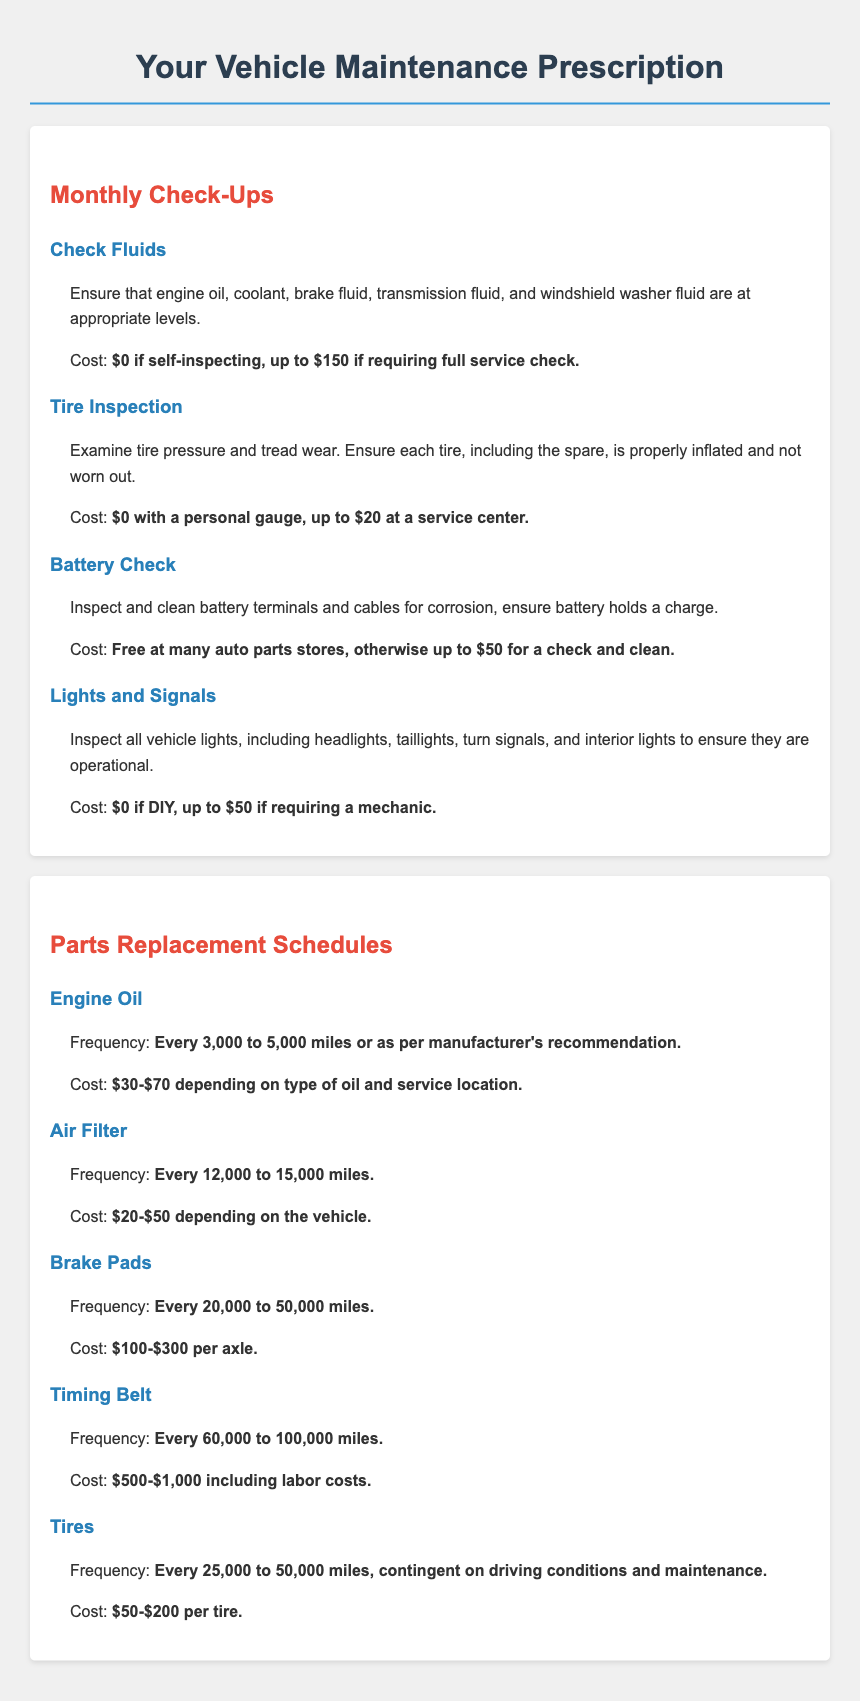What is the cost of checking fluids? The cost for checking fluids can range from $0 for self-inspecting to $150 if requiring a full service check.
Answer: $0 to $150 How often should you check tire pressure and tread wear? The document mentions that tire inspection should be done monthly.
Answer: Monthly What is the cost range for engine oil replacement? The cost for engine oil replacement depends on the type of oil and service location, ranging from $30 to $70.
Answer: $30-$70 When should brake pads typically be replaced? Brake pads should be replaced every 20,000 to 50,000 miles.
Answer: Every 20,000 to 50,000 miles What is the frequency for replacing the air filter? It is recommended to replace the air filter every 12,000 to 15,000 miles.
Answer: Every 12,000 to 15,000 miles How much might you spend on a tire replacement? The document states that tire cost ranges from $50 to $200 per tire.
Answer: $50-$200 What can be done to check the battery? Battery check involves inspecting and cleaning battery terminals and cables.
Answer: Inspect and clean terminals What is the maximum cost for a light and signal inspection? If requiring a mechanic, the maximum cost for light and signal inspection can be up to $50.
Answer: Up to $50 How frequently should the timing belt be replaced? The timing belt should be replaced every 60,000 to 100,000 miles.
Answer: Every 60,000 to 100,000 miles 